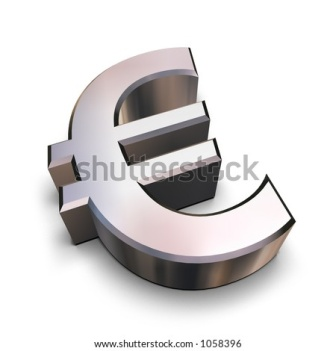How does the design of this symbol influence its perception in the world? The design of the Euro symbol significantly influences its global perception. The clean, modern lines convey a sense of progressiveness and efficiency, while the mirror-like metallic finish suggests wealth and stability. The combination of horizontal and vertical elements reflects balance and coordination, important qualities in economic partnerships. This design ensures that the Euro is not only seen as a currency but also as a powerful symbol of unity and strong governance within the European Union, commanding respect in international markets. Can you create a story about the Euro symbol representing resilience? In the heart of the Digital Realm, where currencies from across the globe coexisted and competed, the Euro symbol stood tall and proud, embodying resilience. It was forged during a tumultuous era when its creators envisioned a harmonious future. As storms of financial crises raged, the Euro symbol faced trials, its lustrous surface sometimes dimmed but never tarnished. It braved the icy winds of recession, the quakes of political upheaval, and the floods of uncertainty, emerging stronger each time. Legends grew around it, inspiring stories of solidarity across nations. It stood as a beacon of hope, a testament to the enduring spirit of unity and cooperation. With each passing year, the Euro symbol's journey was etched into the annals of economic folklore, celebrated as the emblem of fortitude and perseverance. 